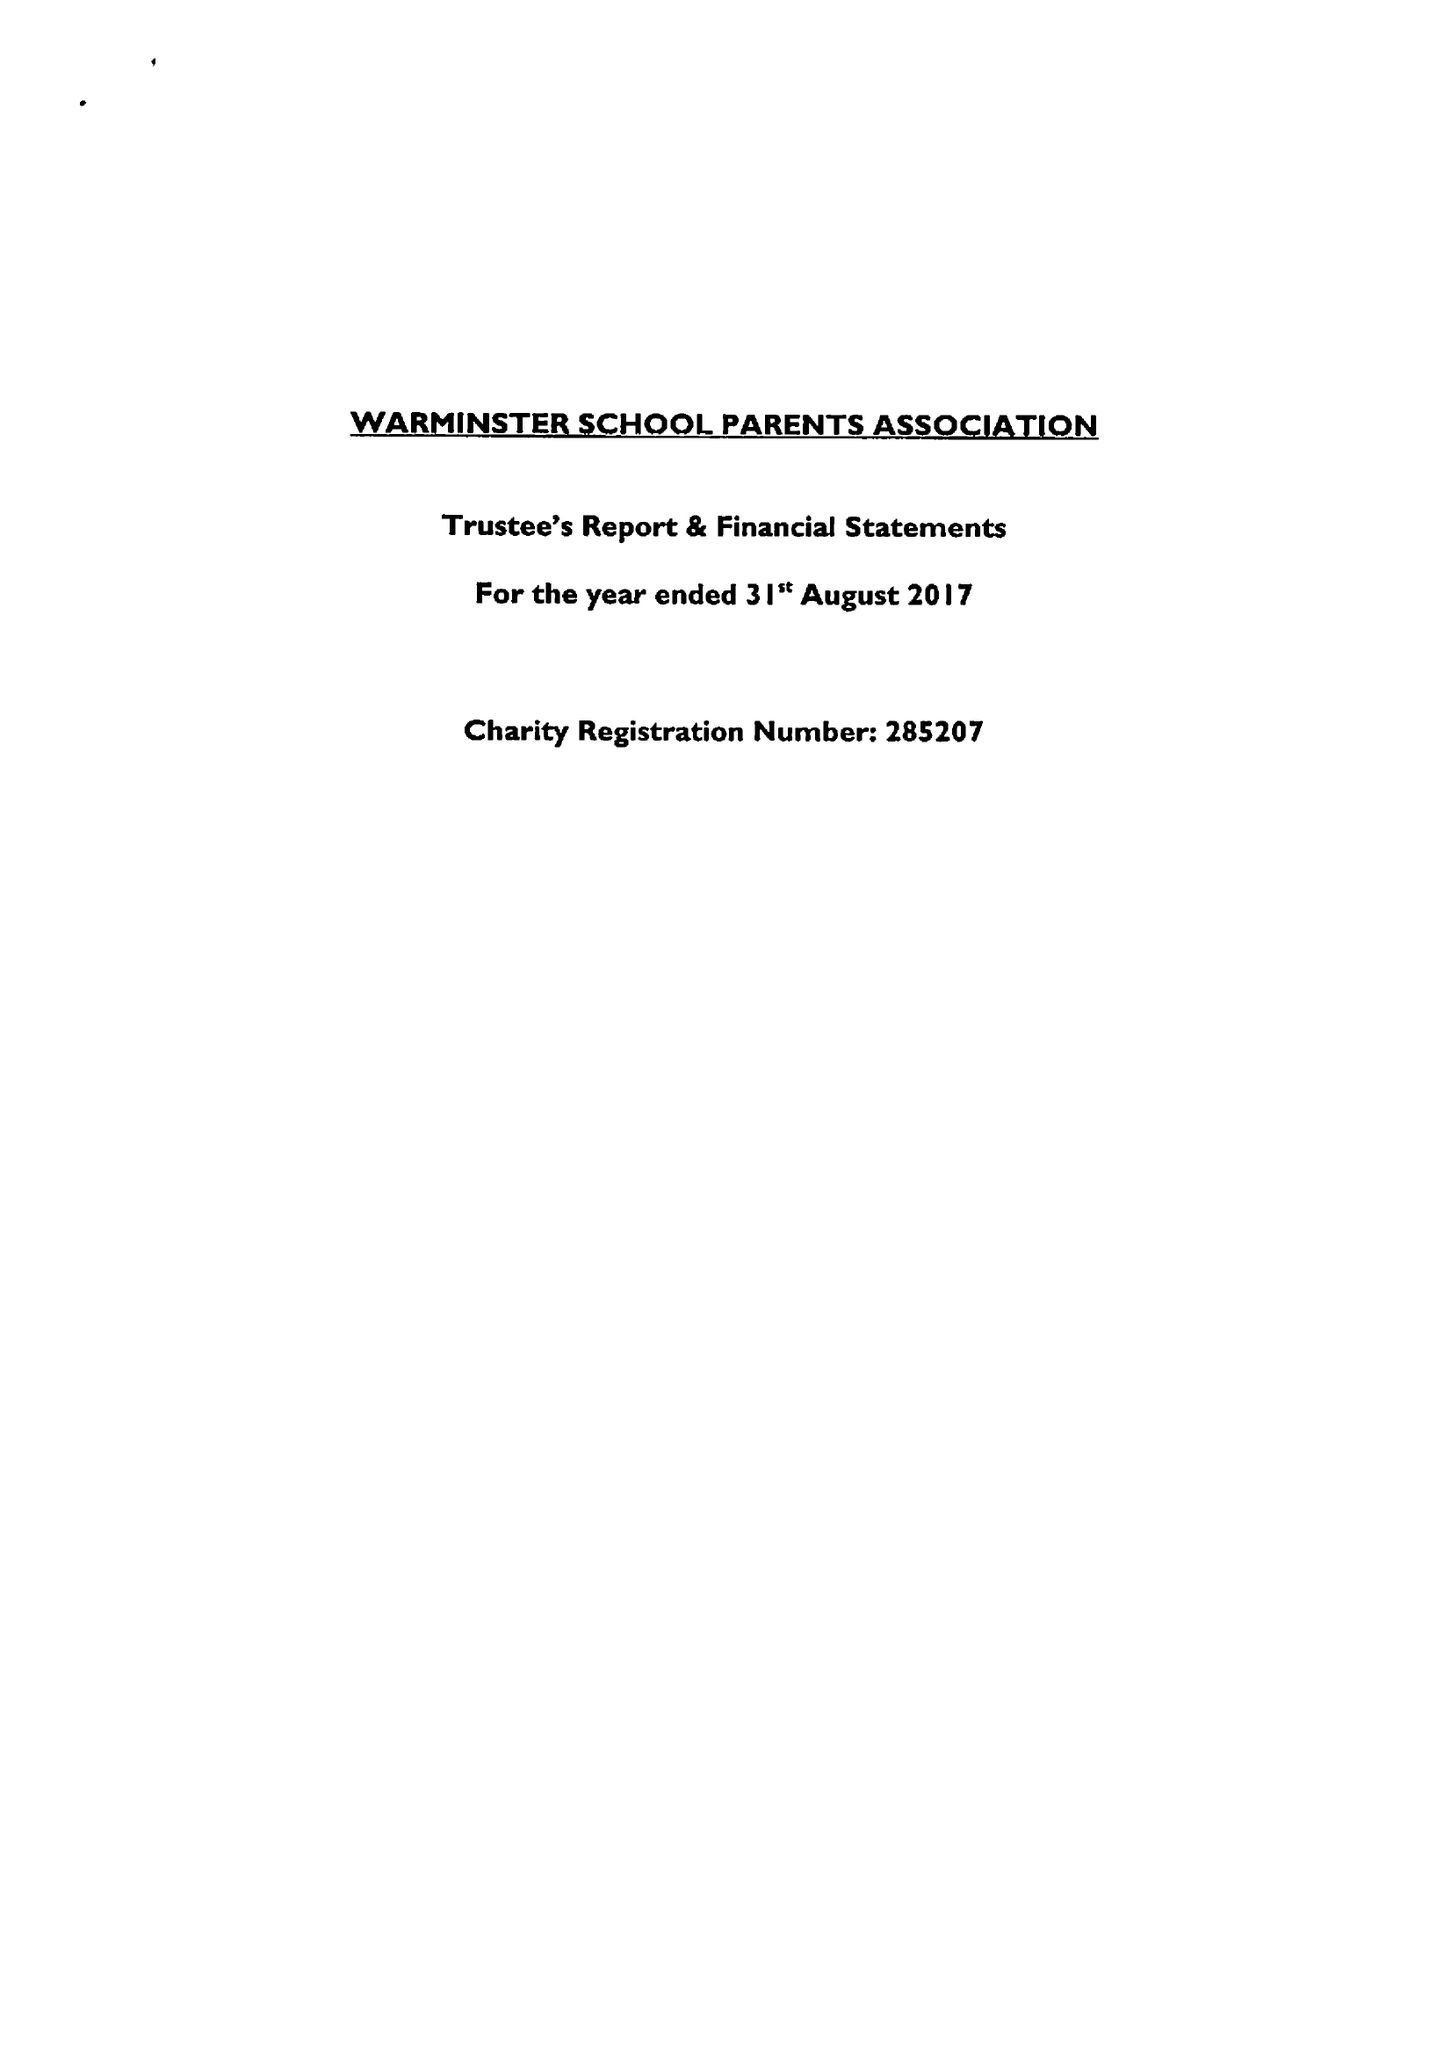What is the value for the spending_annually_in_british_pounds?
Answer the question using a single word or phrase. 17599.00 